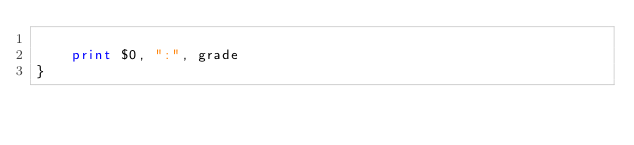Convert code to text. <code><loc_0><loc_0><loc_500><loc_500><_Awk_>    
    print $0, ":", grade
}
</code> 